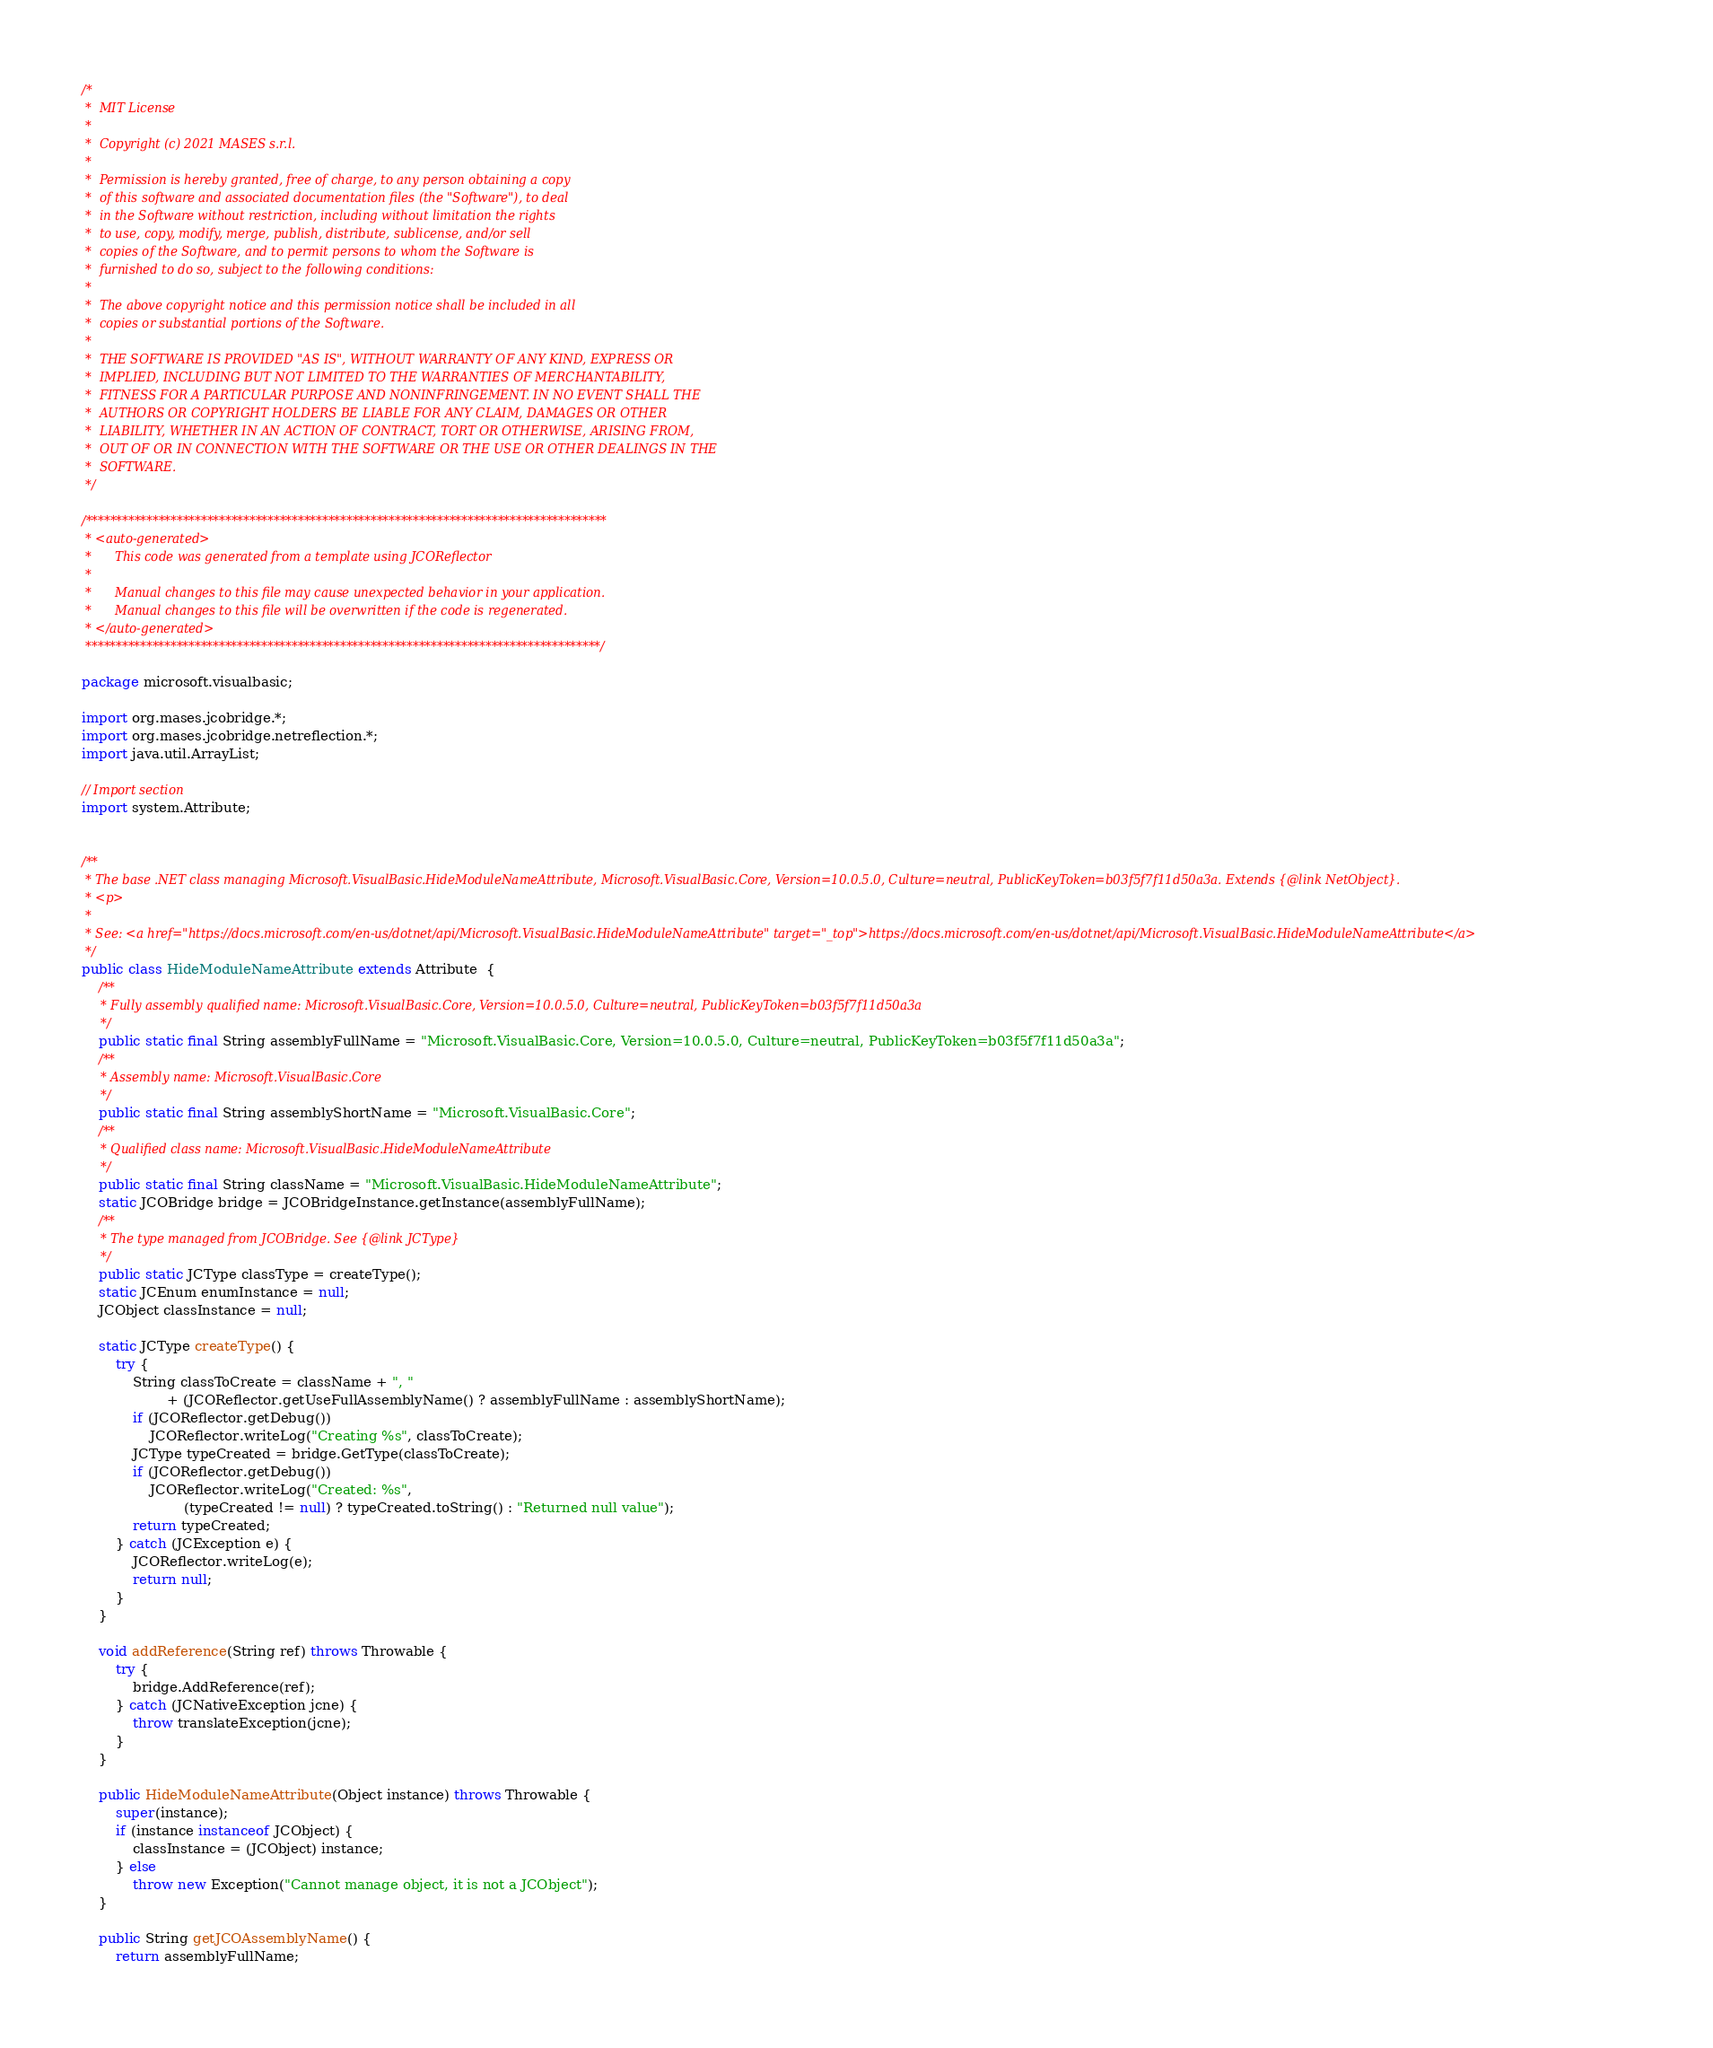Convert code to text. <code><loc_0><loc_0><loc_500><loc_500><_Java_>/*
 *  MIT License
 *
 *  Copyright (c) 2021 MASES s.r.l.
 *
 *  Permission is hereby granted, free of charge, to any person obtaining a copy
 *  of this software and associated documentation files (the "Software"), to deal
 *  in the Software without restriction, including without limitation the rights
 *  to use, copy, modify, merge, publish, distribute, sublicense, and/or sell
 *  copies of the Software, and to permit persons to whom the Software is
 *  furnished to do so, subject to the following conditions:
 *
 *  The above copyright notice and this permission notice shall be included in all
 *  copies or substantial portions of the Software.
 *
 *  THE SOFTWARE IS PROVIDED "AS IS", WITHOUT WARRANTY OF ANY KIND, EXPRESS OR
 *  IMPLIED, INCLUDING BUT NOT LIMITED TO THE WARRANTIES OF MERCHANTABILITY,
 *  FITNESS FOR A PARTICULAR PURPOSE AND NONINFRINGEMENT. IN NO EVENT SHALL THE
 *  AUTHORS OR COPYRIGHT HOLDERS BE LIABLE FOR ANY CLAIM, DAMAGES OR OTHER
 *  LIABILITY, WHETHER IN AN ACTION OF CONTRACT, TORT OR OTHERWISE, ARISING FROM,
 *  OUT OF OR IN CONNECTION WITH THE SOFTWARE OR THE USE OR OTHER DEALINGS IN THE
 *  SOFTWARE.
 */

/**************************************************************************************
 * <auto-generated>
 *      This code was generated from a template using JCOReflector
 * 
 *      Manual changes to this file may cause unexpected behavior in your application.
 *      Manual changes to this file will be overwritten if the code is regenerated.
 * </auto-generated>
 *************************************************************************************/

package microsoft.visualbasic;

import org.mases.jcobridge.*;
import org.mases.jcobridge.netreflection.*;
import java.util.ArrayList;

// Import section
import system.Attribute;


/**
 * The base .NET class managing Microsoft.VisualBasic.HideModuleNameAttribute, Microsoft.VisualBasic.Core, Version=10.0.5.0, Culture=neutral, PublicKeyToken=b03f5f7f11d50a3a. Extends {@link NetObject}.
 * <p>
 * 
 * See: <a href="https://docs.microsoft.com/en-us/dotnet/api/Microsoft.VisualBasic.HideModuleNameAttribute" target="_top">https://docs.microsoft.com/en-us/dotnet/api/Microsoft.VisualBasic.HideModuleNameAttribute</a>
 */
public class HideModuleNameAttribute extends Attribute  {
    /**
     * Fully assembly qualified name: Microsoft.VisualBasic.Core, Version=10.0.5.0, Culture=neutral, PublicKeyToken=b03f5f7f11d50a3a
     */
    public static final String assemblyFullName = "Microsoft.VisualBasic.Core, Version=10.0.5.0, Culture=neutral, PublicKeyToken=b03f5f7f11d50a3a";
    /**
     * Assembly name: Microsoft.VisualBasic.Core
     */
    public static final String assemblyShortName = "Microsoft.VisualBasic.Core";
    /**
     * Qualified class name: Microsoft.VisualBasic.HideModuleNameAttribute
     */
    public static final String className = "Microsoft.VisualBasic.HideModuleNameAttribute";
    static JCOBridge bridge = JCOBridgeInstance.getInstance(assemblyFullName);
    /**
     * The type managed from JCOBridge. See {@link JCType}
     */
    public static JCType classType = createType();
    static JCEnum enumInstance = null;
    JCObject classInstance = null;

    static JCType createType() {
        try {
            String classToCreate = className + ", "
                    + (JCOReflector.getUseFullAssemblyName() ? assemblyFullName : assemblyShortName);
            if (JCOReflector.getDebug())
                JCOReflector.writeLog("Creating %s", classToCreate);
            JCType typeCreated = bridge.GetType(classToCreate);
            if (JCOReflector.getDebug())
                JCOReflector.writeLog("Created: %s",
                        (typeCreated != null) ? typeCreated.toString() : "Returned null value");
            return typeCreated;
        } catch (JCException e) {
            JCOReflector.writeLog(e);
            return null;
        }
    }

    void addReference(String ref) throws Throwable {
        try {
            bridge.AddReference(ref);
        } catch (JCNativeException jcne) {
            throw translateException(jcne);
        }
    }

    public HideModuleNameAttribute(Object instance) throws Throwable {
        super(instance);
        if (instance instanceof JCObject) {
            classInstance = (JCObject) instance;
        } else
            throw new Exception("Cannot manage object, it is not a JCObject");
    }

    public String getJCOAssemblyName() {
        return assemblyFullName;</code> 